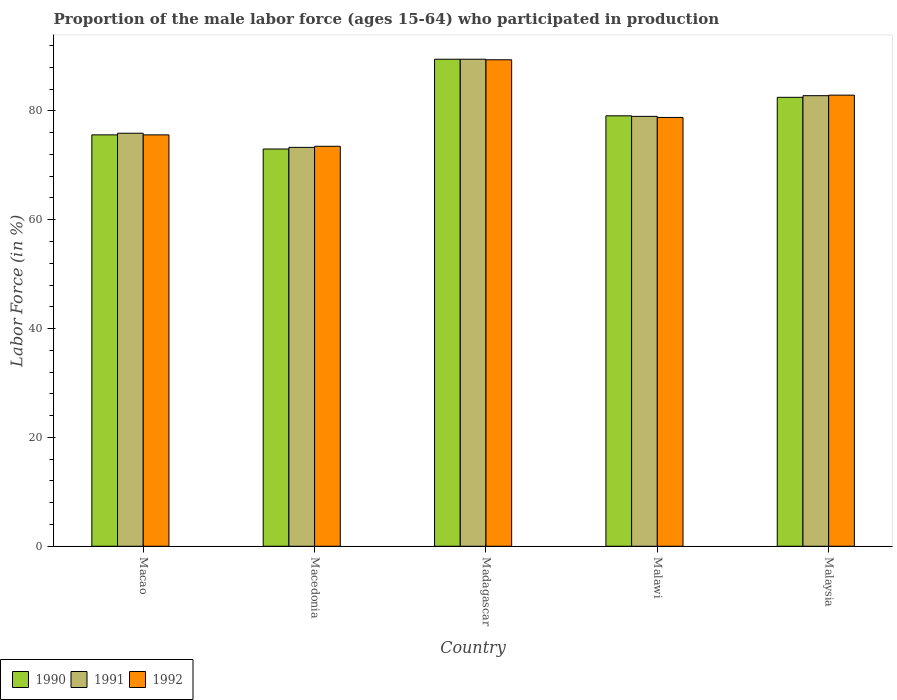How many different coloured bars are there?
Give a very brief answer. 3. Are the number of bars per tick equal to the number of legend labels?
Your answer should be compact. Yes. How many bars are there on the 4th tick from the left?
Give a very brief answer. 3. What is the label of the 2nd group of bars from the left?
Give a very brief answer. Macedonia. In how many cases, is the number of bars for a given country not equal to the number of legend labels?
Your answer should be compact. 0. What is the proportion of the male labor force who participated in production in 1990 in Macedonia?
Make the answer very short. 73. Across all countries, what is the maximum proportion of the male labor force who participated in production in 1990?
Provide a short and direct response. 89.5. Across all countries, what is the minimum proportion of the male labor force who participated in production in 1992?
Ensure brevity in your answer.  73.5. In which country was the proportion of the male labor force who participated in production in 1991 maximum?
Your answer should be compact. Madagascar. In which country was the proportion of the male labor force who participated in production in 1990 minimum?
Offer a very short reply. Macedonia. What is the total proportion of the male labor force who participated in production in 1992 in the graph?
Provide a succinct answer. 400.2. What is the difference between the proportion of the male labor force who participated in production in 1990 in Madagascar and that in Malawi?
Provide a short and direct response. 10.4. What is the difference between the proportion of the male labor force who participated in production in 1992 in Madagascar and the proportion of the male labor force who participated in production in 1990 in Malaysia?
Ensure brevity in your answer.  6.9. What is the average proportion of the male labor force who participated in production in 1992 per country?
Provide a short and direct response. 80.04. What is the difference between the proportion of the male labor force who participated in production of/in 1990 and proportion of the male labor force who participated in production of/in 1991 in Madagascar?
Provide a short and direct response. 0. What is the ratio of the proportion of the male labor force who participated in production in 1992 in Macedonia to that in Madagascar?
Your answer should be compact. 0.82. Is the proportion of the male labor force who participated in production in 1992 in Macedonia less than that in Malaysia?
Provide a short and direct response. Yes. What is the difference between the highest and the second highest proportion of the male labor force who participated in production in 1992?
Keep it short and to the point. 6.5. What is the difference between the highest and the lowest proportion of the male labor force who participated in production in 1992?
Ensure brevity in your answer.  15.9. Does the graph contain grids?
Give a very brief answer. No. How many legend labels are there?
Provide a short and direct response. 3. How are the legend labels stacked?
Offer a terse response. Horizontal. What is the title of the graph?
Offer a very short reply. Proportion of the male labor force (ages 15-64) who participated in production. What is the Labor Force (in %) of 1990 in Macao?
Offer a very short reply. 75.6. What is the Labor Force (in %) of 1991 in Macao?
Make the answer very short. 75.9. What is the Labor Force (in %) in 1992 in Macao?
Your answer should be compact. 75.6. What is the Labor Force (in %) in 1991 in Macedonia?
Provide a short and direct response. 73.3. What is the Labor Force (in %) in 1992 in Macedonia?
Your answer should be very brief. 73.5. What is the Labor Force (in %) of 1990 in Madagascar?
Give a very brief answer. 89.5. What is the Labor Force (in %) in 1991 in Madagascar?
Your response must be concise. 89.5. What is the Labor Force (in %) in 1992 in Madagascar?
Offer a terse response. 89.4. What is the Labor Force (in %) in 1990 in Malawi?
Ensure brevity in your answer.  79.1. What is the Labor Force (in %) in 1991 in Malawi?
Make the answer very short. 79. What is the Labor Force (in %) in 1992 in Malawi?
Your answer should be very brief. 78.8. What is the Labor Force (in %) in 1990 in Malaysia?
Your answer should be very brief. 82.5. What is the Labor Force (in %) in 1991 in Malaysia?
Your answer should be compact. 82.8. What is the Labor Force (in %) in 1992 in Malaysia?
Your answer should be very brief. 82.9. Across all countries, what is the maximum Labor Force (in %) in 1990?
Provide a short and direct response. 89.5. Across all countries, what is the maximum Labor Force (in %) of 1991?
Provide a short and direct response. 89.5. Across all countries, what is the maximum Labor Force (in %) of 1992?
Provide a short and direct response. 89.4. Across all countries, what is the minimum Labor Force (in %) in 1991?
Your response must be concise. 73.3. Across all countries, what is the minimum Labor Force (in %) of 1992?
Keep it short and to the point. 73.5. What is the total Labor Force (in %) of 1990 in the graph?
Keep it short and to the point. 399.7. What is the total Labor Force (in %) of 1991 in the graph?
Make the answer very short. 400.5. What is the total Labor Force (in %) of 1992 in the graph?
Make the answer very short. 400.2. What is the difference between the Labor Force (in %) in 1991 in Macao and that in Macedonia?
Provide a short and direct response. 2.6. What is the difference between the Labor Force (in %) of 1990 in Macao and that in Malawi?
Your response must be concise. -3.5. What is the difference between the Labor Force (in %) in 1991 in Macao and that in Malawi?
Make the answer very short. -3.1. What is the difference between the Labor Force (in %) of 1991 in Macao and that in Malaysia?
Your response must be concise. -6.9. What is the difference between the Labor Force (in %) in 1990 in Macedonia and that in Madagascar?
Ensure brevity in your answer.  -16.5. What is the difference between the Labor Force (in %) in 1991 in Macedonia and that in Madagascar?
Make the answer very short. -16.2. What is the difference between the Labor Force (in %) in 1992 in Macedonia and that in Madagascar?
Provide a short and direct response. -15.9. What is the difference between the Labor Force (in %) of 1990 in Macedonia and that in Malawi?
Ensure brevity in your answer.  -6.1. What is the difference between the Labor Force (in %) of 1991 in Macedonia and that in Malawi?
Your answer should be very brief. -5.7. What is the difference between the Labor Force (in %) of 1991 in Madagascar and that in Malawi?
Offer a terse response. 10.5. What is the difference between the Labor Force (in %) in 1990 in Malawi and that in Malaysia?
Make the answer very short. -3.4. What is the difference between the Labor Force (in %) of 1990 in Macao and the Labor Force (in %) of 1991 in Macedonia?
Your response must be concise. 2.3. What is the difference between the Labor Force (in %) in 1990 in Macao and the Labor Force (in %) in 1992 in Macedonia?
Your answer should be very brief. 2.1. What is the difference between the Labor Force (in %) in 1991 in Macao and the Labor Force (in %) in 1992 in Macedonia?
Offer a very short reply. 2.4. What is the difference between the Labor Force (in %) in 1990 in Macao and the Labor Force (in %) in 1991 in Madagascar?
Make the answer very short. -13.9. What is the difference between the Labor Force (in %) of 1990 in Macao and the Labor Force (in %) of 1992 in Madagascar?
Keep it short and to the point. -13.8. What is the difference between the Labor Force (in %) of 1991 in Macao and the Labor Force (in %) of 1992 in Madagascar?
Give a very brief answer. -13.5. What is the difference between the Labor Force (in %) of 1990 in Macao and the Labor Force (in %) of 1991 in Malawi?
Provide a short and direct response. -3.4. What is the difference between the Labor Force (in %) of 1990 in Macao and the Labor Force (in %) of 1992 in Malawi?
Keep it short and to the point. -3.2. What is the difference between the Labor Force (in %) of 1990 in Macedonia and the Labor Force (in %) of 1991 in Madagascar?
Ensure brevity in your answer.  -16.5. What is the difference between the Labor Force (in %) in 1990 in Macedonia and the Labor Force (in %) in 1992 in Madagascar?
Keep it short and to the point. -16.4. What is the difference between the Labor Force (in %) in 1991 in Macedonia and the Labor Force (in %) in 1992 in Madagascar?
Provide a short and direct response. -16.1. What is the difference between the Labor Force (in %) in 1990 in Macedonia and the Labor Force (in %) in 1991 in Malawi?
Offer a terse response. -6. What is the difference between the Labor Force (in %) of 1990 in Macedonia and the Labor Force (in %) of 1992 in Malawi?
Make the answer very short. -5.8. What is the difference between the Labor Force (in %) in 1991 in Macedonia and the Labor Force (in %) in 1992 in Malawi?
Provide a succinct answer. -5.5. What is the difference between the Labor Force (in %) in 1990 in Macedonia and the Labor Force (in %) in 1991 in Malaysia?
Keep it short and to the point. -9.8. What is the difference between the Labor Force (in %) in 1990 in Macedonia and the Labor Force (in %) in 1992 in Malaysia?
Provide a short and direct response. -9.9. What is the difference between the Labor Force (in %) of 1991 in Macedonia and the Labor Force (in %) of 1992 in Malaysia?
Ensure brevity in your answer.  -9.6. What is the difference between the Labor Force (in %) in 1990 in Madagascar and the Labor Force (in %) in 1991 in Malawi?
Keep it short and to the point. 10.5. What is the difference between the Labor Force (in %) in 1990 in Madagascar and the Labor Force (in %) in 1991 in Malaysia?
Offer a very short reply. 6.7. What is the difference between the Labor Force (in %) of 1990 in Madagascar and the Labor Force (in %) of 1992 in Malaysia?
Provide a short and direct response. 6.6. What is the difference between the Labor Force (in %) in 1991 in Madagascar and the Labor Force (in %) in 1992 in Malaysia?
Offer a terse response. 6.6. What is the difference between the Labor Force (in %) of 1990 in Malawi and the Labor Force (in %) of 1991 in Malaysia?
Make the answer very short. -3.7. What is the average Labor Force (in %) of 1990 per country?
Offer a terse response. 79.94. What is the average Labor Force (in %) in 1991 per country?
Keep it short and to the point. 80.1. What is the average Labor Force (in %) of 1992 per country?
Provide a succinct answer. 80.04. What is the difference between the Labor Force (in %) in 1990 and Labor Force (in %) in 1991 in Macao?
Ensure brevity in your answer.  -0.3. What is the difference between the Labor Force (in %) of 1990 and Labor Force (in %) of 1992 in Macao?
Offer a terse response. 0. What is the difference between the Labor Force (in %) of 1990 and Labor Force (in %) of 1992 in Macedonia?
Your response must be concise. -0.5. What is the difference between the Labor Force (in %) of 1990 and Labor Force (in %) of 1991 in Madagascar?
Your answer should be very brief. 0. What is the difference between the Labor Force (in %) in 1990 and Labor Force (in %) in 1992 in Madagascar?
Offer a terse response. 0.1. What is the difference between the Labor Force (in %) of 1991 and Labor Force (in %) of 1992 in Madagascar?
Provide a short and direct response. 0.1. What is the difference between the Labor Force (in %) in 1990 and Labor Force (in %) in 1991 in Malawi?
Give a very brief answer. 0.1. What is the difference between the Labor Force (in %) of 1990 and Labor Force (in %) of 1992 in Malawi?
Make the answer very short. 0.3. What is the difference between the Labor Force (in %) in 1991 and Labor Force (in %) in 1992 in Malawi?
Offer a terse response. 0.2. What is the difference between the Labor Force (in %) in 1990 and Labor Force (in %) in 1991 in Malaysia?
Your response must be concise. -0.3. What is the ratio of the Labor Force (in %) in 1990 in Macao to that in Macedonia?
Provide a short and direct response. 1.04. What is the ratio of the Labor Force (in %) in 1991 in Macao to that in Macedonia?
Provide a succinct answer. 1.04. What is the ratio of the Labor Force (in %) of 1992 in Macao to that in Macedonia?
Make the answer very short. 1.03. What is the ratio of the Labor Force (in %) in 1990 in Macao to that in Madagascar?
Provide a short and direct response. 0.84. What is the ratio of the Labor Force (in %) in 1991 in Macao to that in Madagascar?
Keep it short and to the point. 0.85. What is the ratio of the Labor Force (in %) in 1992 in Macao to that in Madagascar?
Your response must be concise. 0.85. What is the ratio of the Labor Force (in %) of 1990 in Macao to that in Malawi?
Offer a very short reply. 0.96. What is the ratio of the Labor Force (in %) in 1991 in Macao to that in Malawi?
Provide a short and direct response. 0.96. What is the ratio of the Labor Force (in %) in 1992 in Macao to that in Malawi?
Provide a short and direct response. 0.96. What is the ratio of the Labor Force (in %) in 1990 in Macao to that in Malaysia?
Offer a terse response. 0.92. What is the ratio of the Labor Force (in %) in 1992 in Macao to that in Malaysia?
Your answer should be compact. 0.91. What is the ratio of the Labor Force (in %) of 1990 in Macedonia to that in Madagascar?
Your answer should be compact. 0.82. What is the ratio of the Labor Force (in %) in 1991 in Macedonia to that in Madagascar?
Your response must be concise. 0.82. What is the ratio of the Labor Force (in %) of 1992 in Macedonia to that in Madagascar?
Give a very brief answer. 0.82. What is the ratio of the Labor Force (in %) in 1990 in Macedonia to that in Malawi?
Your answer should be very brief. 0.92. What is the ratio of the Labor Force (in %) in 1991 in Macedonia to that in Malawi?
Keep it short and to the point. 0.93. What is the ratio of the Labor Force (in %) of 1992 in Macedonia to that in Malawi?
Provide a succinct answer. 0.93. What is the ratio of the Labor Force (in %) in 1990 in Macedonia to that in Malaysia?
Give a very brief answer. 0.88. What is the ratio of the Labor Force (in %) in 1991 in Macedonia to that in Malaysia?
Provide a succinct answer. 0.89. What is the ratio of the Labor Force (in %) in 1992 in Macedonia to that in Malaysia?
Your answer should be very brief. 0.89. What is the ratio of the Labor Force (in %) in 1990 in Madagascar to that in Malawi?
Make the answer very short. 1.13. What is the ratio of the Labor Force (in %) of 1991 in Madagascar to that in Malawi?
Keep it short and to the point. 1.13. What is the ratio of the Labor Force (in %) of 1992 in Madagascar to that in Malawi?
Make the answer very short. 1.13. What is the ratio of the Labor Force (in %) of 1990 in Madagascar to that in Malaysia?
Offer a terse response. 1.08. What is the ratio of the Labor Force (in %) in 1991 in Madagascar to that in Malaysia?
Offer a terse response. 1.08. What is the ratio of the Labor Force (in %) in 1992 in Madagascar to that in Malaysia?
Provide a succinct answer. 1.08. What is the ratio of the Labor Force (in %) of 1990 in Malawi to that in Malaysia?
Make the answer very short. 0.96. What is the ratio of the Labor Force (in %) in 1991 in Malawi to that in Malaysia?
Keep it short and to the point. 0.95. What is the ratio of the Labor Force (in %) in 1992 in Malawi to that in Malaysia?
Provide a succinct answer. 0.95. What is the difference between the highest and the second highest Labor Force (in %) of 1990?
Offer a very short reply. 7. What is the difference between the highest and the second highest Labor Force (in %) in 1992?
Provide a short and direct response. 6.5. What is the difference between the highest and the lowest Labor Force (in %) in 1990?
Ensure brevity in your answer.  16.5. What is the difference between the highest and the lowest Labor Force (in %) in 1992?
Your answer should be compact. 15.9. 